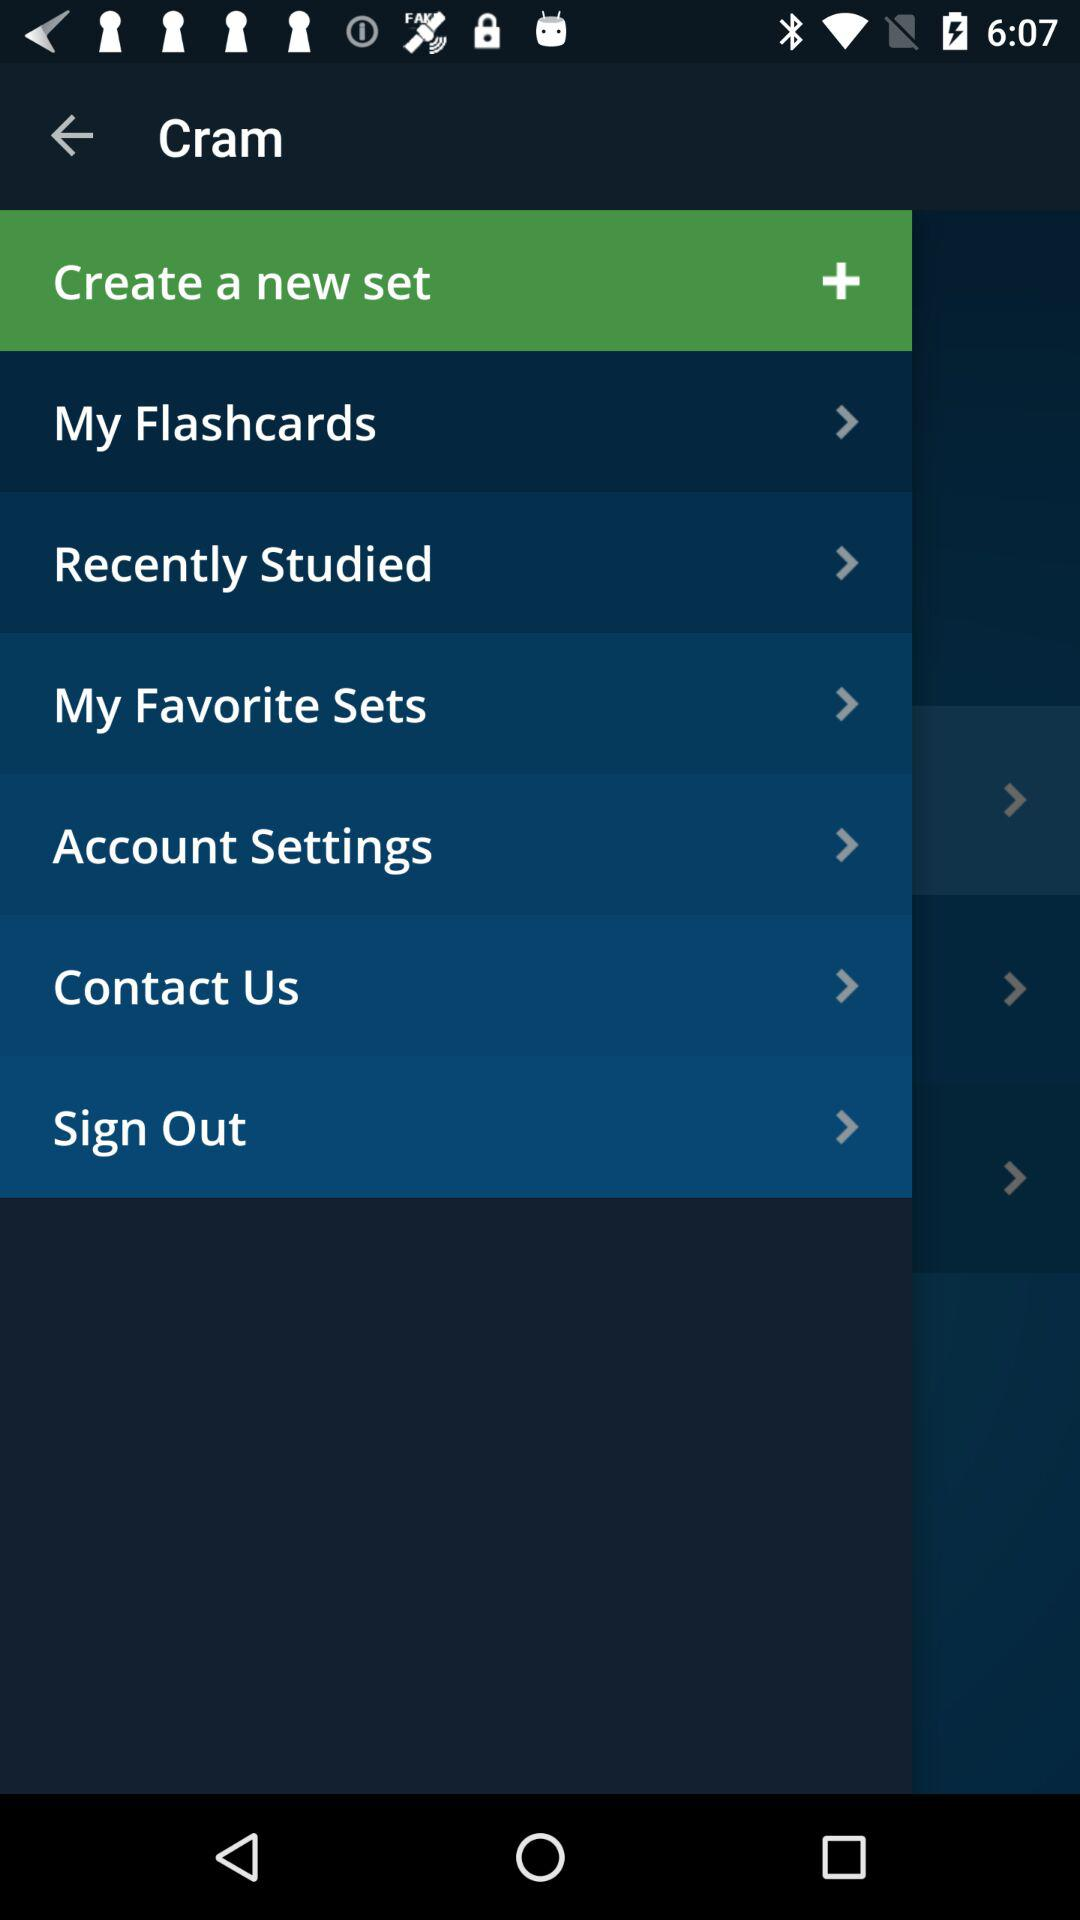What is the application name? The name of the application is "Cram". 